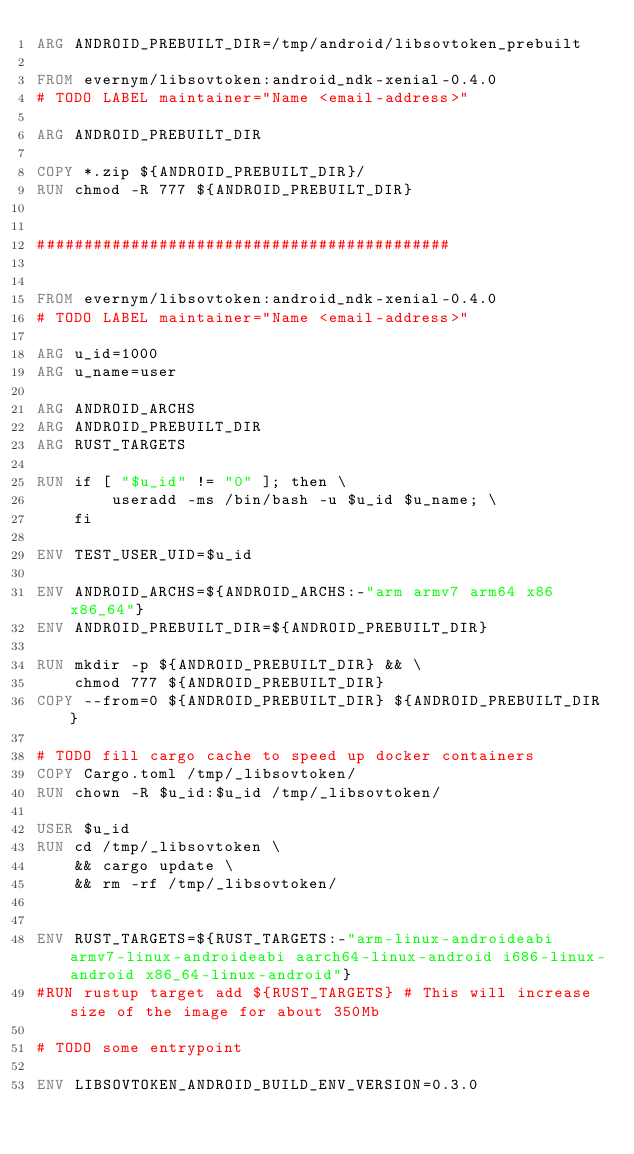Convert code to text. <code><loc_0><loc_0><loc_500><loc_500><_Dockerfile_>ARG ANDROID_PREBUILT_DIR=/tmp/android/libsovtoken_prebuilt

FROM evernym/libsovtoken:android_ndk-xenial-0.4.0
# TODO LABEL maintainer="Name <email-address>"

ARG ANDROID_PREBUILT_DIR

COPY *.zip ${ANDROID_PREBUILT_DIR}/
RUN chmod -R 777 ${ANDROID_PREBUILT_DIR}


############################################


FROM evernym/libsovtoken:android_ndk-xenial-0.4.0
# TODO LABEL maintainer="Name <email-address>"

ARG u_id=1000
ARG u_name=user

ARG ANDROID_ARCHS
ARG ANDROID_PREBUILT_DIR
ARG RUST_TARGETS

RUN if [ "$u_id" != "0" ]; then \
        useradd -ms /bin/bash -u $u_id $u_name; \
    fi

ENV TEST_USER_UID=$u_id

ENV ANDROID_ARCHS=${ANDROID_ARCHS:-"arm armv7 arm64 x86 x86_64"}
ENV ANDROID_PREBUILT_DIR=${ANDROID_PREBUILT_DIR}

RUN mkdir -p ${ANDROID_PREBUILT_DIR} && \
    chmod 777 ${ANDROID_PREBUILT_DIR}
COPY --from=0 ${ANDROID_PREBUILT_DIR} ${ANDROID_PREBUILT_DIR}

# TODO fill cargo cache to speed up docker containers
COPY Cargo.toml /tmp/_libsovtoken/
RUN chown -R $u_id:$u_id /tmp/_libsovtoken/

USER $u_id
RUN cd /tmp/_libsovtoken \
    && cargo update \
    && rm -rf /tmp/_libsovtoken/


ENV RUST_TARGETS=${RUST_TARGETS:-"arm-linux-androideabi armv7-linux-androideabi aarch64-linux-android i686-linux-android x86_64-linux-android"}
#RUN rustup target add ${RUST_TARGETS} # This will increase size of the image for about 350Mb

# TODO some entrypoint

ENV LIBSOVTOKEN_ANDROID_BUILD_ENV_VERSION=0.3.0
</code> 